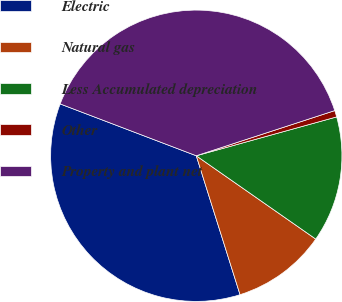<chart> <loc_0><loc_0><loc_500><loc_500><pie_chart><fcel>Electric<fcel>Natural gas<fcel>Less Accumulated depreciation<fcel>Other<fcel>Property and plant net<nl><fcel>35.65%<fcel>10.45%<fcel>13.99%<fcel>0.72%<fcel>39.19%<nl></chart> 